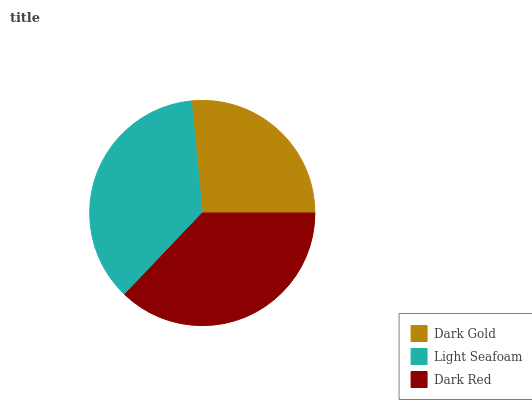Is Dark Gold the minimum?
Answer yes or no. Yes. Is Dark Red the maximum?
Answer yes or no. Yes. Is Light Seafoam the minimum?
Answer yes or no. No. Is Light Seafoam the maximum?
Answer yes or no. No. Is Light Seafoam greater than Dark Gold?
Answer yes or no. Yes. Is Dark Gold less than Light Seafoam?
Answer yes or no. Yes. Is Dark Gold greater than Light Seafoam?
Answer yes or no. No. Is Light Seafoam less than Dark Gold?
Answer yes or no. No. Is Light Seafoam the high median?
Answer yes or no. Yes. Is Light Seafoam the low median?
Answer yes or no. Yes. Is Dark Gold the high median?
Answer yes or no. No. Is Dark Red the low median?
Answer yes or no. No. 